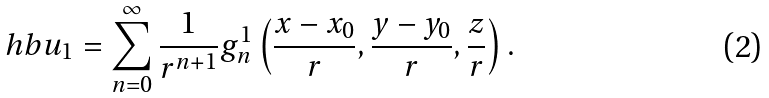<formula> <loc_0><loc_0><loc_500><loc_500>\ h b u _ { 1 } = \sum _ { n = 0 } ^ { \infty } \frac { 1 } { r ^ { n + 1 } } g _ { n } ^ { 1 } \left ( \frac { x - x _ { 0 } } { r } , \frac { y - y _ { 0 } } { r } , \frac { z } { r } \right ) .</formula> 